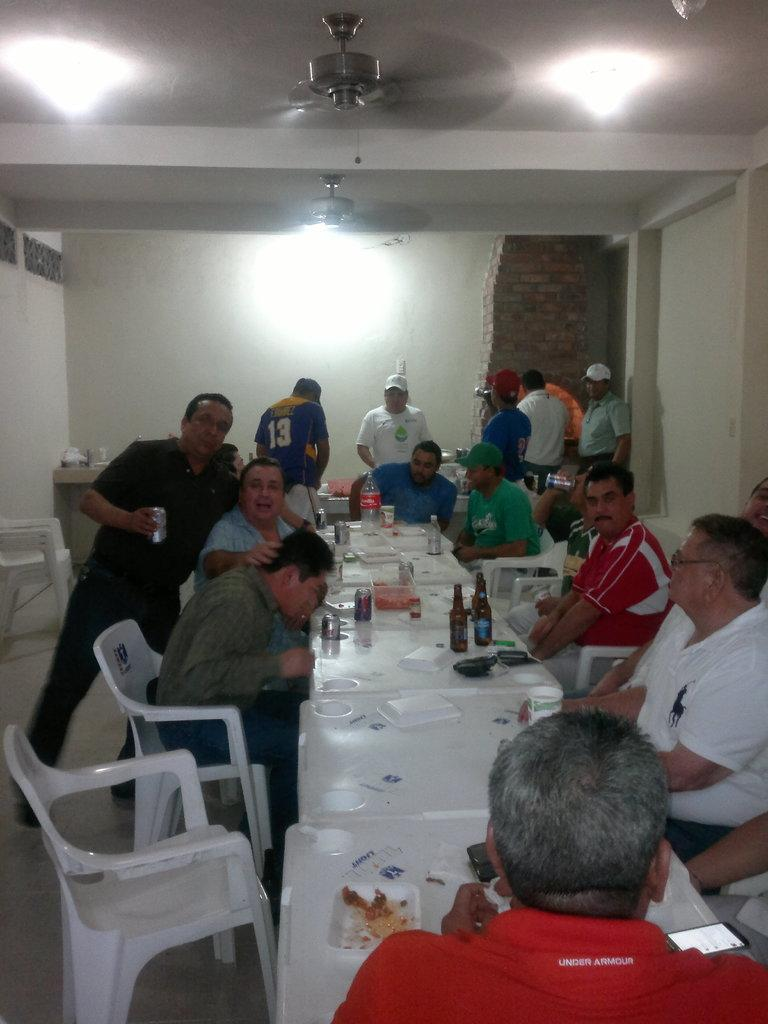What are the people in the image doing? The persons in the image are standing and sitting around the table. What objects can be seen on the table? There is a bottle, glasses, a can, and plates on the table. What is the background of the image? There is a wall in the background of the image. How many girls are present in the image? The provided facts do not mention the gender of the persons in the image, so it is impossible to determine the number of girls present. 